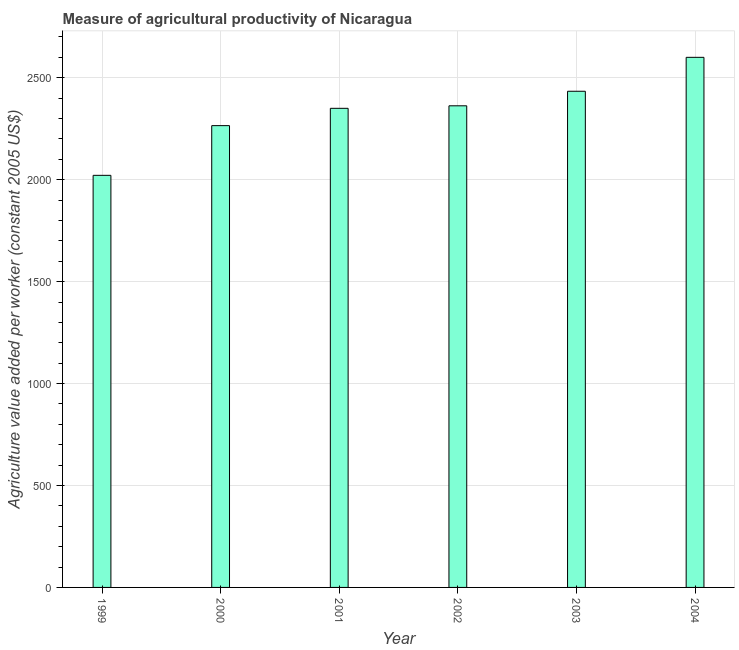Does the graph contain any zero values?
Your response must be concise. No. What is the title of the graph?
Give a very brief answer. Measure of agricultural productivity of Nicaragua. What is the label or title of the Y-axis?
Your response must be concise. Agriculture value added per worker (constant 2005 US$). What is the agriculture value added per worker in 2004?
Offer a terse response. 2600.17. Across all years, what is the maximum agriculture value added per worker?
Make the answer very short. 2600.17. Across all years, what is the minimum agriculture value added per worker?
Your answer should be very brief. 2021.32. In which year was the agriculture value added per worker maximum?
Your answer should be very brief. 2004. In which year was the agriculture value added per worker minimum?
Your answer should be very brief. 1999. What is the sum of the agriculture value added per worker?
Provide a short and direct response. 1.40e+04. What is the difference between the agriculture value added per worker in 2000 and 2004?
Offer a very short reply. -335. What is the average agriculture value added per worker per year?
Your response must be concise. 2338.82. What is the median agriculture value added per worker?
Make the answer very short. 2356.23. Do a majority of the years between 1999 and 2003 (inclusive) have agriculture value added per worker greater than 2600 US$?
Provide a succinct answer. No. What is the ratio of the agriculture value added per worker in 1999 to that in 2003?
Offer a terse response. 0.83. What is the difference between the highest and the second highest agriculture value added per worker?
Your response must be concise. 166.39. What is the difference between the highest and the lowest agriculture value added per worker?
Provide a short and direct response. 578.85. How many bars are there?
Make the answer very short. 6. Are all the bars in the graph horizontal?
Provide a short and direct response. No. What is the difference between two consecutive major ticks on the Y-axis?
Make the answer very short. 500. What is the Agriculture value added per worker (constant 2005 US$) of 1999?
Provide a succinct answer. 2021.32. What is the Agriculture value added per worker (constant 2005 US$) of 2000?
Your answer should be compact. 2265.17. What is the Agriculture value added per worker (constant 2005 US$) in 2001?
Keep it short and to the point. 2350.07. What is the Agriculture value added per worker (constant 2005 US$) in 2002?
Give a very brief answer. 2362.4. What is the Agriculture value added per worker (constant 2005 US$) in 2003?
Offer a very short reply. 2433.78. What is the Agriculture value added per worker (constant 2005 US$) of 2004?
Offer a terse response. 2600.17. What is the difference between the Agriculture value added per worker (constant 2005 US$) in 1999 and 2000?
Your response must be concise. -243.86. What is the difference between the Agriculture value added per worker (constant 2005 US$) in 1999 and 2001?
Ensure brevity in your answer.  -328.75. What is the difference between the Agriculture value added per worker (constant 2005 US$) in 1999 and 2002?
Keep it short and to the point. -341.08. What is the difference between the Agriculture value added per worker (constant 2005 US$) in 1999 and 2003?
Offer a terse response. -412.47. What is the difference between the Agriculture value added per worker (constant 2005 US$) in 1999 and 2004?
Give a very brief answer. -578.85. What is the difference between the Agriculture value added per worker (constant 2005 US$) in 2000 and 2001?
Make the answer very short. -84.89. What is the difference between the Agriculture value added per worker (constant 2005 US$) in 2000 and 2002?
Provide a succinct answer. -97.22. What is the difference between the Agriculture value added per worker (constant 2005 US$) in 2000 and 2003?
Provide a succinct answer. -168.61. What is the difference between the Agriculture value added per worker (constant 2005 US$) in 2000 and 2004?
Make the answer very short. -335. What is the difference between the Agriculture value added per worker (constant 2005 US$) in 2001 and 2002?
Offer a very short reply. -12.33. What is the difference between the Agriculture value added per worker (constant 2005 US$) in 2001 and 2003?
Your answer should be compact. -83.72. What is the difference between the Agriculture value added per worker (constant 2005 US$) in 2001 and 2004?
Ensure brevity in your answer.  -250.1. What is the difference between the Agriculture value added per worker (constant 2005 US$) in 2002 and 2003?
Give a very brief answer. -71.39. What is the difference between the Agriculture value added per worker (constant 2005 US$) in 2002 and 2004?
Your answer should be compact. -237.78. What is the difference between the Agriculture value added per worker (constant 2005 US$) in 2003 and 2004?
Give a very brief answer. -166.39. What is the ratio of the Agriculture value added per worker (constant 2005 US$) in 1999 to that in 2000?
Offer a very short reply. 0.89. What is the ratio of the Agriculture value added per worker (constant 2005 US$) in 1999 to that in 2001?
Give a very brief answer. 0.86. What is the ratio of the Agriculture value added per worker (constant 2005 US$) in 1999 to that in 2002?
Offer a very short reply. 0.86. What is the ratio of the Agriculture value added per worker (constant 2005 US$) in 1999 to that in 2003?
Your response must be concise. 0.83. What is the ratio of the Agriculture value added per worker (constant 2005 US$) in 1999 to that in 2004?
Give a very brief answer. 0.78. What is the ratio of the Agriculture value added per worker (constant 2005 US$) in 2000 to that in 2004?
Your answer should be very brief. 0.87. What is the ratio of the Agriculture value added per worker (constant 2005 US$) in 2001 to that in 2004?
Ensure brevity in your answer.  0.9. What is the ratio of the Agriculture value added per worker (constant 2005 US$) in 2002 to that in 2004?
Give a very brief answer. 0.91. What is the ratio of the Agriculture value added per worker (constant 2005 US$) in 2003 to that in 2004?
Your answer should be very brief. 0.94. 